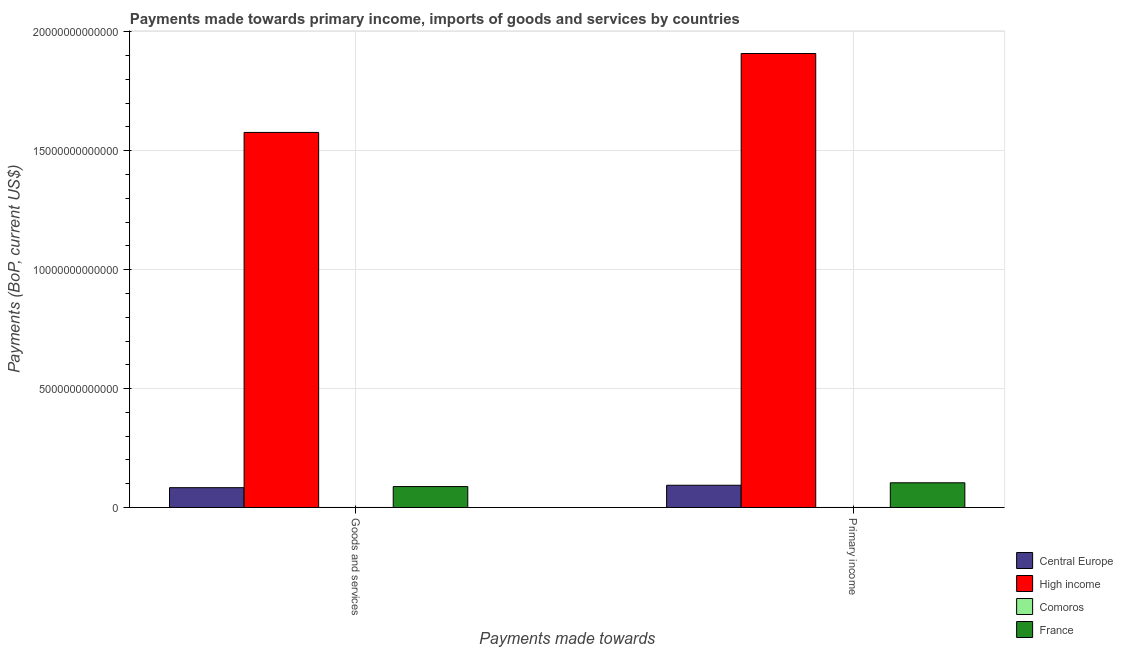How many different coloured bars are there?
Keep it short and to the point. 4. How many groups of bars are there?
Make the answer very short. 2. How many bars are there on the 2nd tick from the right?
Your answer should be compact. 4. What is the label of the 1st group of bars from the left?
Keep it short and to the point. Goods and services. What is the payments made towards goods and services in Comoros?
Your answer should be compact. 3.07e+08. Across all countries, what is the maximum payments made towards goods and services?
Provide a short and direct response. 1.58e+13. Across all countries, what is the minimum payments made towards primary income?
Ensure brevity in your answer.  3.12e+08. In which country was the payments made towards primary income maximum?
Your response must be concise. High income. In which country was the payments made towards primary income minimum?
Keep it short and to the point. Comoros. What is the total payments made towards goods and services in the graph?
Ensure brevity in your answer.  1.75e+13. What is the difference between the payments made towards goods and services in Comoros and that in High income?
Keep it short and to the point. -1.58e+13. What is the difference between the payments made towards primary income in Central Europe and the payments made towards goods and services in France?
Offer a terse response. 5.50e+1. What is the average payments made towards primary income per country?
Ensure brevity in your answer.  5.27e+12. What is the difference between the payments made towards goods and services and payments made towards primary income in France?
Offer a terse response. -1.59e+11. What is the ratio of the payments made towards primary income in France to that in Central Europe?
Offer a very short reply. 1.11. In how many countries, is the payments made towards primary income greater than the average payments made towards primary income taken over all countries?
Provide a short and direct response. 1. What does the 4th bar from the right in Primary income represents?
Your answer should be compact. Central Europe. How many bars are there?
Make the answer very short. 8. Are all the bars in the graph horizontal?
Provide a succinct answer. No. How many countries are there in the graph?
Offer a very short reply. 4. What is the difference between two consecutive major ticks on the Y-axis?
Your answer should be very brief. 5.00e+12. Are the values on the major ticks of Y-axis written in scientific E-notation?
Your answer should be compact. No. Does the graph contain any zero values?
Your answer should be compact. No. Does the graph contain grids?
Offer a very short reply. Yes. How are the legend labels stacked?
Make the answer very short. Vertical. What is the title of the graph?
Your response must be concise. Payments made towards primary income, imports of goods and services by countries. What is the label or title of the X-axis?
Your answer should be compact. Payments made towards. What is the label or title of the Y-axis?
Give a very brief answer. Payments (BoP, current US$). What is the Payments (BoP, current US$) of Central Europe in Goods and services?
Provide a short and direct response. 8.33e+11. What is the Payments (BoP, current US$) in High income in Goods and services?
Keep it short and to the point. 1.58e+13. What is the Payments (BoP, current US$) of Comoros in Goods and services?
Offer a terse response. 3.07e+08. What is the Payments (BoP, current US$) of France in Goods and services?
Your answer should be very brief. 8.80e+11. What is the Payments (BoP, current US$) in Central Europe in Primary income?
Offer a terse response. 9.35e+11. What is the Payments (BoP, current US$) in High income in Primary income?
Offer a very short reply. 1.91e+13. What is the Payments (BoP, current US$) in Comoros in Primary income?
Give a very brief answer. 3.12e+08. What is the Payments (BoP, current US$) of France in Primary income?
Provide a succinct answer. 1.04e+12. Across all Payments made towards, what is the maximum Payments (BoP, current US$) in Central Europe?
Your answer should be compact. 9.35e+11. Across all Payments made towards, what is the maximum Payments (BoP, current US$) in High income?
Offer a terse response. 1.91e+13. Across all Payments made towards, what is the maximum Payments (BoP, current US$) in Comoros?
Keep it short and to the point. 3.12e+08. Across all Payments made towards, what is the maximum Payments (BoP, current US$) in France?
Your answer should be very brief. 1.04e+12. Across all Payments made towards, what is the minimum Payments (BoP, current US$) of Central Europe?
Offer a very short reply. 8.33e+11. Across all Payments made towards, what is the minimum Payments (BoP, current US$) in High income?
Offer a terse response. 1.58e+13. Across all Payments made towards, what is the minimum Payments (BoP, current US$) in Comoros?
Give a very brief answer. 3.07e+08. Across all Payments made towards, what is the minimum Payments (BoP, current US$) of France?
Offer a very short reply. 8.80e+11. What is the total Payments (BoP, current US$) in Central Europe in the graph?
Keep it short and to the point. 1.77e+12. What is the total Payments (BoP, current US$) in High income in the graph?
Offer a very short reply. 3.49e+13. What is the total Payments (BoP, current US$) in Comoros in the graph?
Offer a very short reply. 6.19e+08. What is the total Payments (BoP, current US$) of France in the graph?
Keep it short and to the point. 1.92e+12. What is the difference between the Payments (BoP, current US$) of Central Europe in Goods and services and that in Primary income?
Keep it short and to the point. -1.02e+11. What is the difference between the Payments (BoP, current US$) in High income in Goods and services and that in Primary income?
Make the answer very short. -3.32e+12. What is the difference between the Payments (BoP, current US$) in Comoros in Goods and services and that in Primary income?
Offer a very short reply. -4.58e+06. What is the difference between the Payments (BoP, current US$) in France in Goods and services and that in Primary income?
Offer a very short reply. -1.59e+11. What is the difference between the Payments (BoP, current US$) in Central Europe in Goods and services and the Payments (BoP, current US$) in High income in Primary income?
Provide a short and direct response. -1.83e+13. What is the difference between the Payments (BoP, current US$) of Central Europe in Goods and services and the Payments (BoP, current US$) of Comoros in Primary income?
Give a very brief answer. 8.32e+11. What is the difference between the Payments (BoP, current US$) in Central Europe in Goods and services and the Payments (BoP, current US$) in France in Primary income?
Your answer should be very brief. -2.06e+11. What is the difference between the Payments (BoP, current US$) of High income in Goods and services and the Payments (BoP, current US$) of Comoros in Primary income?
Keep it short and to the point. 1.58e+13. What is the difference between the Payments (BoP, current US$) in High income in Goods and services and the Payments (BoP, current US$) in France in Primary income?
Offer a very short reply. 1.47e+13. What is the difference between the Payments (BoP, current US$) of Comoros in Goods and services and the Payments (BoP, current US$) of France in Primary income?
Offer a very short reply. -1.04e+12. What is the average Payments (BoP, current US$) in Central Europe per Payments made towards?
Your answer should be very brief. 8.84e+11. What is the average Payments (BoP, current US$) of High income per Payments made towards?
Keep it short and to the point. 1.74e+13. What is the average Payments (BoP, current US$) of Comoros per Payments made towards?
Ensure brevity in your answer.  3.09e+08. What is the average Payments (BoP, current US$) of France per Payments made towards?
Keep it short and to the point. 9.59e+11. What is the difference between the Payments (BoP, current US$) in Central Europe and Payments (BoP, current US$) in High income in Goods and services?
Offer a very short reply. -1.49e+13. What is the difference between the Payments (BoP, current US$) of Central Europe and Payments (BoP, current US$) of Comoros in Goods and services?
Your answer should be compact. 8.32e+11. What is the difference between the Payments (BoP, current US$) in Central Europe and Payments (BoP, current US$) in France in Goods and services?
Give a very brief answer. -4.71e+1. What is the difference between the Payments (BoP, current US$) in High income and Payments (BoP, current US$) in Comoros in Goods and services?
Your response must be concise. 1.58e+13. What is the difference between the Payments (BoP, current US$) in High income and Payments (BoP, current US$) in France in Goods and services?
Ensure brevity in your answer.  1.49e+13. What is the difference between the Payments (BoP, current US$) of Comoros and Payments (BoP, current US$) of France in Goods and services?
Make the answer very short. -8.79e+11. What is the difference between the Payments (BoP, current US$) of Central Europe and Payments (BoP, current US$) of High income in Primary income?
Make the answer very short. -1.82e+13. What is the difference between the Payments (BoP, current US$) in Central Europe and Payments (BoP, current US$) in Comoros in Primary income?
Make the answer very short. 9.34e+11. What is the difference between the Payments (BoP, current US$) of Central Europe and Payments (BoP, current US$) of France in Primary income?
Offer a terse response. -1.04e+11. What is the difference between the Payments (BoP, current US$) of High income and Payments (BoP, current US$) of Comoros in Primary income?
Provide a short and direct response. 1.91e+13. What is the difference between the Payments (BoP, current US$) in High income and Payments (BoP, current US$) in France in Primary income?
Make the answer very short. 1.80e+13. What is the difference between the Payments (BoP, current US$) in Comoros and Payments (BoP, current US$) in France in Primary income?
Give a very brief answer. -1.04e+12. What is the ratio of the Payments (BoP, current US$) of Central Europe in Goods and services to that in Primary income?
Your response must be concise. 0.89. What is the ratio of the Payments (BoP, current US$) of High income in Goods and services to that in Primary income?
Provide a short and direct response. 0.83. What is the ratio of the Payments (BoP, current US$) in France in Goods and services to that in Primary income?
Make the answer very short. 0.85. What is the difference between the highest and the second highest Payments (BoP, current US$) of Central Europe?
Your answer should be compact. 1.02e+11. What is the difference between the highest and the second highest Payments (BoP, current US$) of High income?
Keep it short and to the point. 3.32e+12. What is the difference between the highest and the second highest Payments (BoP, current US$) in Comoros?
Provide a short and direct response. 4.58e+06. What is the difference between the highest and the second highest Payments (BoP, current US$) in France?
Your response must be concise. 1.59e+11. What is the difference between the highest and the lowest Payments (BoP, current US$) in Central Europe?
Offer a very short reply. 1.02e+11. What is the difference between the highest and the lowest Payments (BoP, current US$) of High income?
Your answer should be very brief. 3.32e+12. What is the difference between the highest and the lowest Payments (BoP, current US$) in Comoros?
Your answer should be compact. 4.58e+06. What is the difference between the highest and the lowest Payments (BoP, current US$) of France?
Offer a terse response. 1.59e+11. 